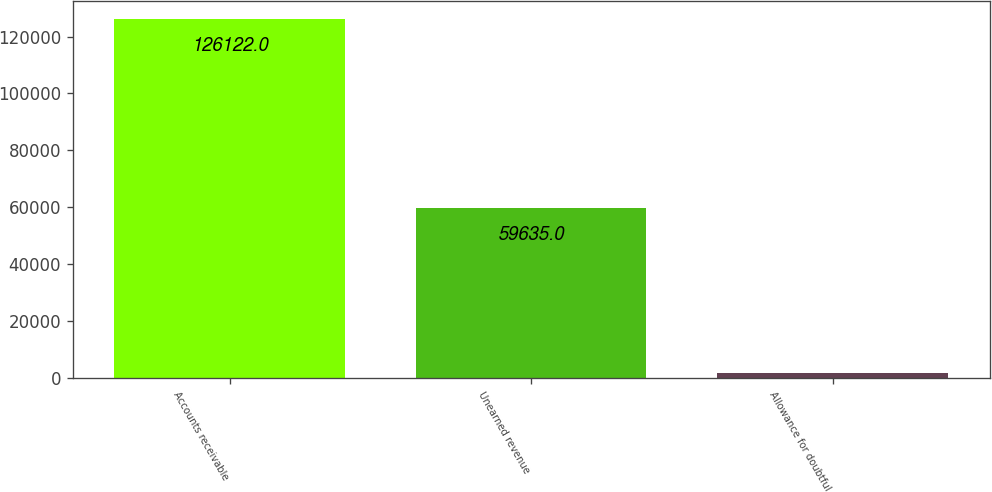Convert chart. <chart><loc_0><loc_0><loc_500><loc_500><bar_chart><fcel>Accounts receivable<fcel>Unearned revenue<fcel>Allowance for doubtful<nl><fcel>126122<fcel>59635<fcel>1720<nl></chart> 